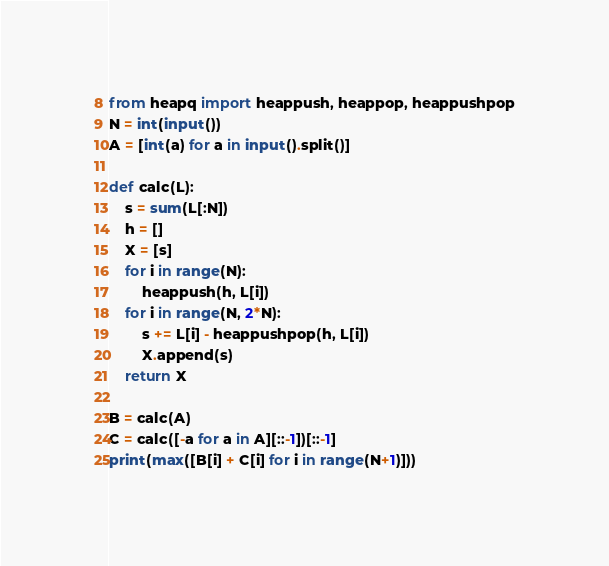<code> <loc_0><loc_0><loc_500><loc_500><_Python_>from heapq import heappush, heappop, heappushpop
N = int(input())
A = [int(a) for a in input().split()]

def calc(L):
    s = sum(L[:N])
    h = []
    X = [s]
    for i in range(N):
        heappush(h, L[i])
    for i in range(N, 2*N):
        s += L[i] - heappushpop(h, L[i])
        X.append(s)
    return X

B = calc(A)
C = calc([-a for a in A][::-1])[::-1]
print(max([B[i] + C[i] for i in range(N+1)]))</code> 